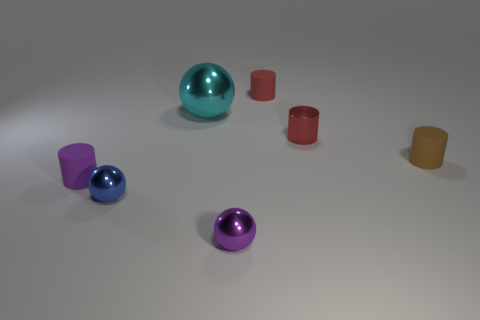What is the texture of these objects and do they seem to be made of the same material? The objects in the image appear to have a smooth and reflective texture, suggestive of a metallic surface. While they come in different colors, their material properties seem quite similar, giving off a unified aesthetic. 